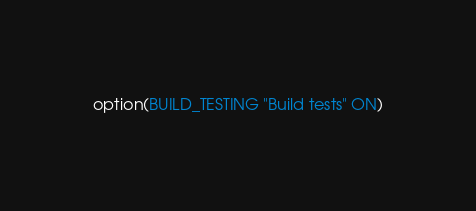<code> <loc_0><loc_0><loc_500><loc_500><_CMake_>option(BUILD_TESTING "Build tests" ON)
</code> 